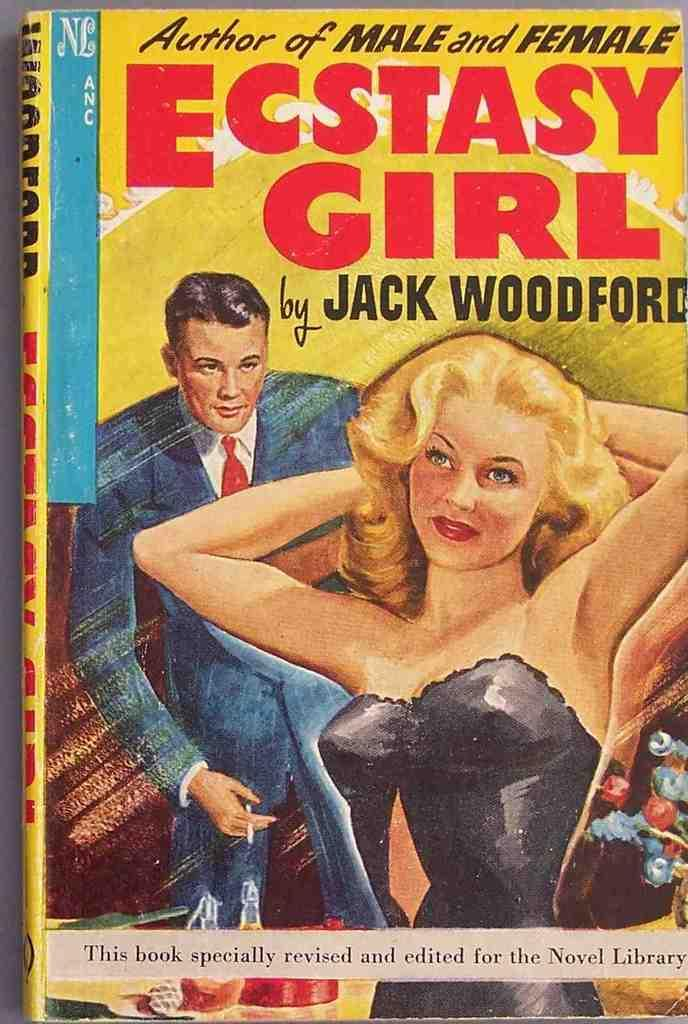<image>
Share a concise interpretation of the image provided. A novel called Ecstasy Girl, written by author Jack Woodford. 